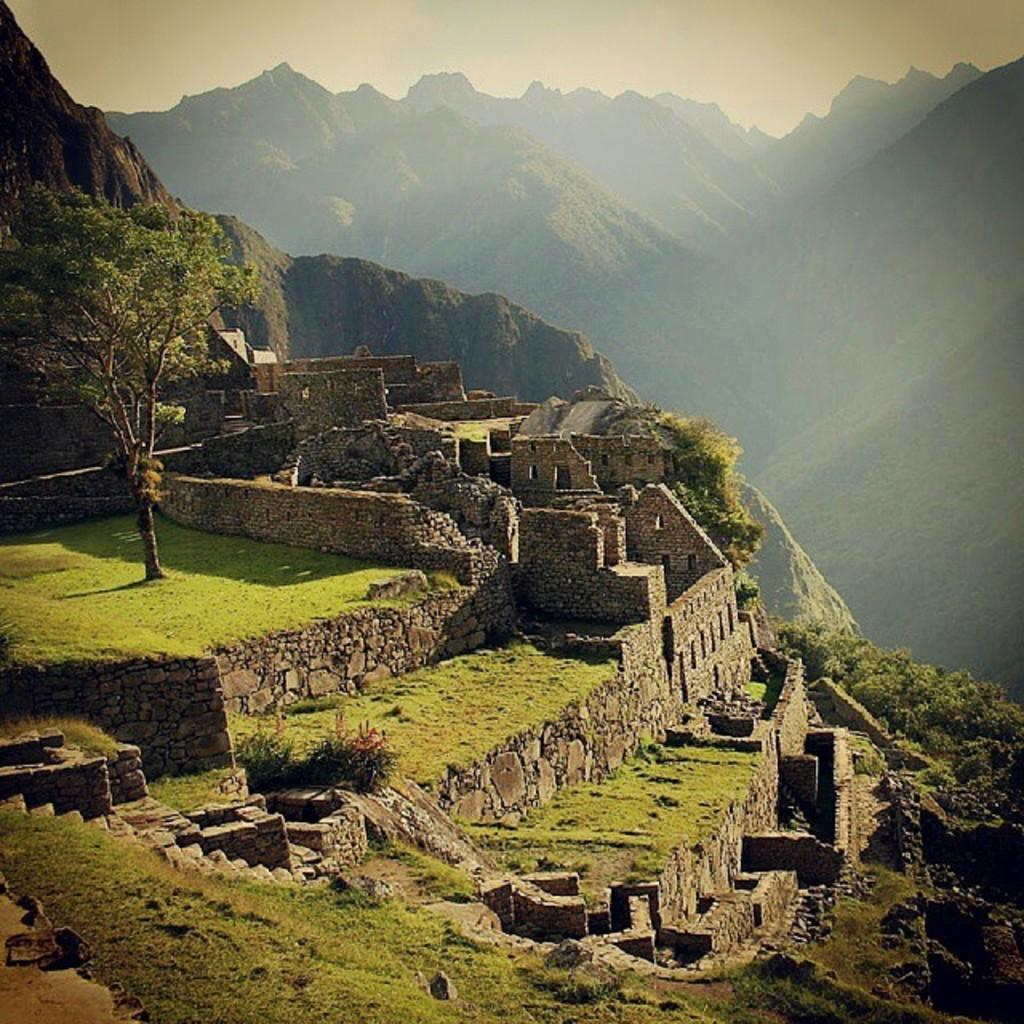What structure can be seen on the mountain in the image? There is a fort on the mountain in the image. What type of vegetation is present on the mountain? There are trees, plants, and grass on the mountain in the image. What can be seen in the background of the image? There are mountains visible in the background of the image. What is visible at the top of the image? The sky is visible at the top of the image. Where is the store located on the mountain in the image? There is no store present on the mountain in the image. What type of quilt is draped over the fort in the image? There is no quilt present in the image; it features a fort, vegetation, and the sky. 